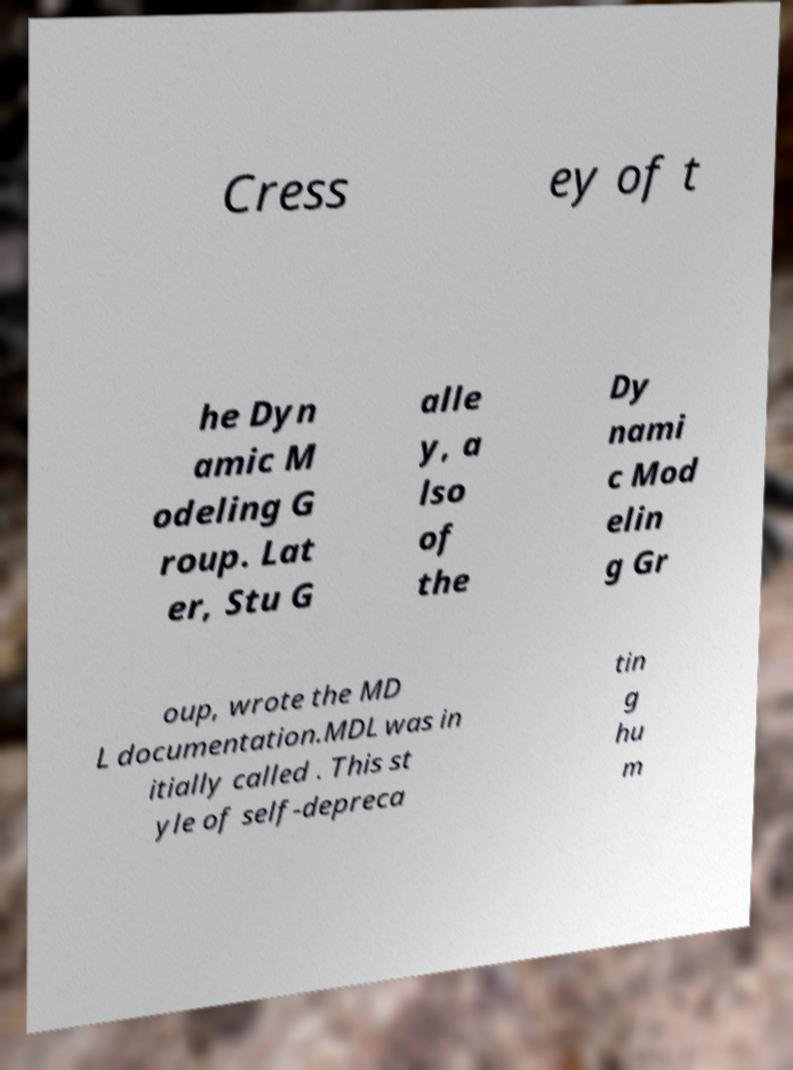For documentation purposes, I need the text within this image transcribed. Could you provide that? Cress ey of t he Dyn amic M odeling G roup. Lat er, Stu G alle y, a lso of the Dy nami c Mod elin g Gr oup, wrote the MD L documentation.MDL was in itially called . This st yle of self-depreca tin g hu m 